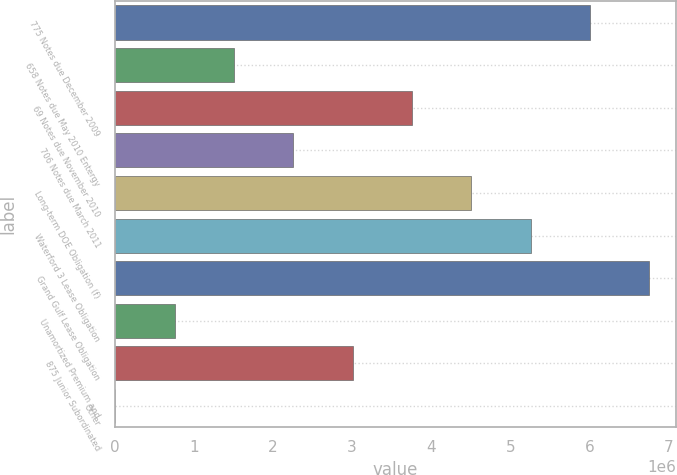Convert chart to OTSL. <chart><loc_0><loc_0><loc_500><loc_500><bar_chart><fcel>775 Notes due December 2009<fcel>658 Notes due May 2010 Entergy<fcel>69 Notes due November 2010<fcel>706 Notes due March 2011<fcel>Long-term DOE Obligation (f)<fcel>Waterford 3 Lease Obligation<fcel>Grand Gulf Lease Obligation<fcel>Unamortized Premium and<fcel>875 Junior Subordinated<fcel>Other<nl><fcel>6.00941e+06<fcel>1.50944e+06<fcel>3.75943e+06<fcel>2.25944e+06<fcel>4.50942e+06<fcel>5.25941e+06<fcel>6.7594e+06<fcel>759451<fcel>3.00943e+06<fcel>9457<nl></chart> 